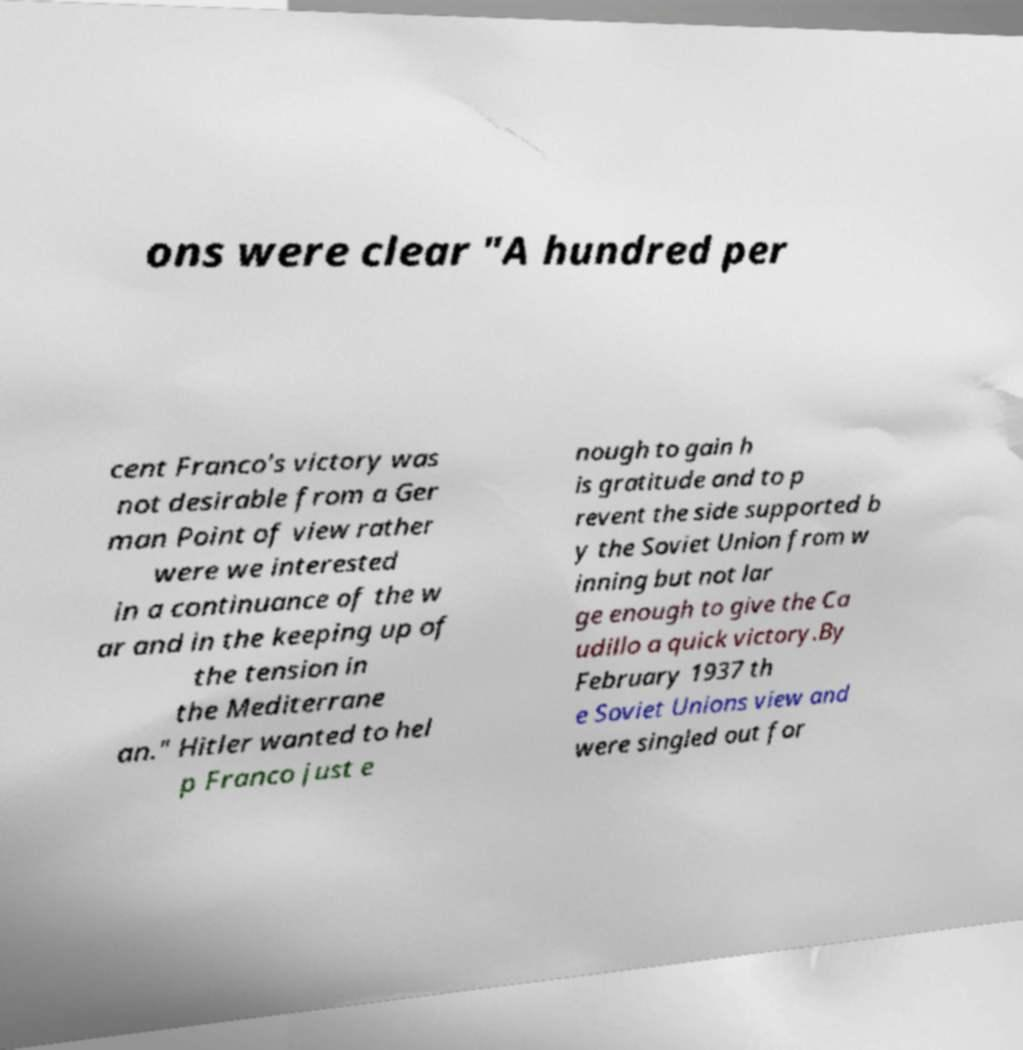Can you accurately transcribe the text from the provided image for me? ons were clear "A hundred per cent Franco's victory was not desirable from a Ger man Point of view rather were we interested in a continuance of the w ar and in the keeping up of the tension in the Mediterrane an." Hitler wanted to hel p Franco just e nough to gain h is gratitude and to p revent the side supported b y the Soviet Union from w inning but not lar ge enough to give the Ca udillo a quick victory.By February 1937 th e Soviet Unions view and were singled out for 